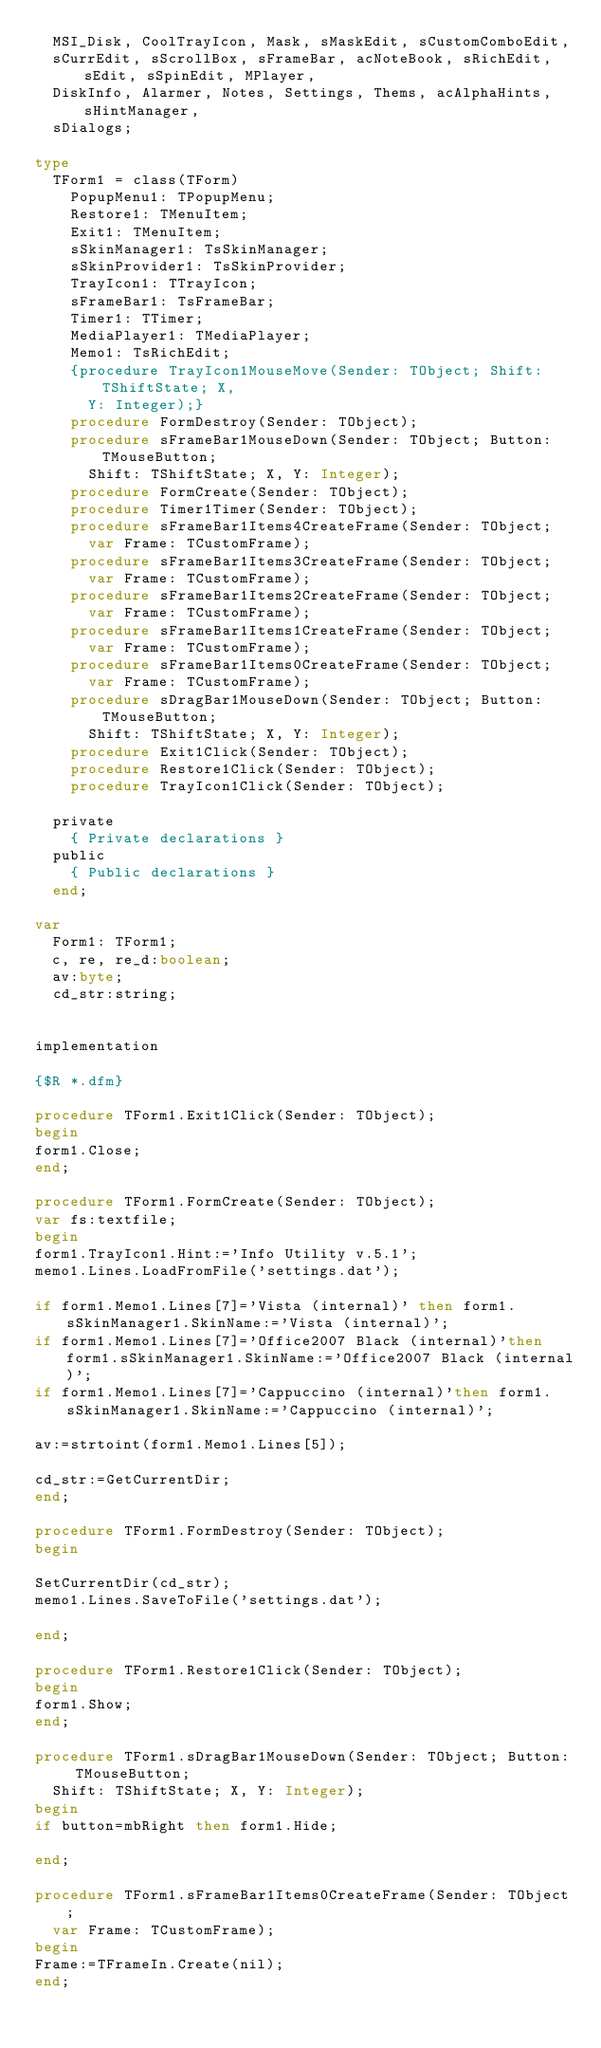Convert code to text. <code><loc_0><loc_0><loc_500><loc_500><_Pascal_>  MSI_Disk, CoolTrayIcon, Mask, sMaskEdit, sCustomComboEdit,
  sCurrEdit, sScrollBox, sFrameBar, acNoteBook, sRichEdit, sEdit, sSpinEdit, MPlayer,
  DiskInfo, Alarmer, Notes, Settings, Thems, acAlphaHints, sHintManager,
  sDialogs;

type
  TForm1 = class(TForm)
    PopupMenu1: TPopupMenu;
    Restore1: TMenuItem;
    Exit1: TMenuItem;
    sSkinManager1: TsSkinManager;
    sSkinProvider1: TsSkinProvider;
    TrayIcon1: TTrayIcon;
    sFrameBar1: TsFrameBar;
    Timer1: TTimer;
    MediaPlayer1: TMediaPlayer;
    Memo1: TsRichEdit;
    {procedure TrayIcon1MouseMove(Sender: TObject; Shift: TShiftState; X,
      Y: Integer);}
    procedure FormDestroy(Sender: TObject);
    procedure sFrameBar1MouseDown(Sender: TObject; Button: TMouseButton;
      Shift: TShiftState; X, Y: Integer);
    procedure FormCreate(Sender: TObject);
    procedure Timer1Timer(Sender: TObject);
    procedure sFrameBar1Items4CreateFrame(Sender: TObject;
      var Frame: TCustomFrame);
    procedure sFrameBar1Items3CreateFrame(Sender: TObject;
      var Frame: TCustomFrame);
    procedure sFrameBar1Items2CreateFrame(Sender: TObject;
      var Frame: TCustomFrame);
    procedure sFrameBar1Items1CreateFrame(Sender: TObject;
      var Frame: TCustomFrame);
    procedure sFrameBar1Items0CreateFrame(Sender: TObject;
      var Frame: TCustomFrame);
    procedure sDragBar1MouseDown(Sender: TObject; Button: TMouseButton;
      Shift: TShiftState; X, Y: Integer);
    procedure Exit1Click(Sender: TObject);
    procedure Restore1Click(Sender: TObject);
    procedure TrayIcon1Click(Sender: TObject);

  private
    { Private declarations }
  public
    { Public declarations }
  end;

var
  Form1: TForm1;
  c, re, re_d:boolean;
  av:byte;
  cd_str:string;


implementation

{$R *.dfm}

procedure TForm1.Exit1Click(Sender: TObject);
begin
form1.Close;
end;

procedure TForm1.FormCreate(Sender: TObject);
var fs:textfile;
begin
form1.TrayIcon1.Hint:='Info Utility v.5.1';
memo1.Lines.LoadFromFile('settings.dat');

if form1.Memo1.Lines[7]='Vista (internal)' then form1.sSkinManager1.SkinName:='Vista (internal)';
if form1.Memo1.Lines[7]='Office2007 Black (internal)'then form1.sSkinManager1.SkinName:='Office2007 Black (internal)';
if form1.Memo1.Lines[7]='Cappuccino (internal)'then form1.sSkinManager1.SkinName:='Cappuccino (internal)';

av:=strtoint(form1.Memo1.Lines[5]);

cd_str:=GetCurrentDir;
end;

procedure TForm1.FormDestroy(Sender: TObject);
begin

SetCurrentDir(cd_str);
memo1.Lines.SaveToFile('settings.dat');

end;

procedure TForm1.Restore1Click(Sender: TObject);
begin
form1.Show;
end;

procedure TForm1.sDragBar1MouseDown(Sender: TObject; Button: TMouseButton;
  Shift: TShiftState; X, Y: Integer);
begin
if button=mbRight then form1.Hide;

end;

procedure TForm1.sFrameBar1Items0CreateFrame(Sender: TObject;
  var Frame: TCustomFrame);
begin
Frame:=TFrameIn.Create(nil);
end;
</code> 